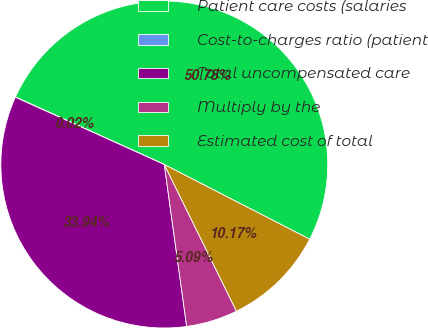Convert chart. <chart><loc_0><loc_0><loc_500><loc_500><pie_chart><fcel>Patient care costs (salaries<fcel>Cost-to-charges ratio (patient<fcel>Total uncompensated care<fcel>Multiply by the<fcel>Estimated cost of total<nl><fcel>50.78%<fcel>0.02%<fcel>33.94%<fcel>5.09%<fcel>10.17%<nl></chart> 